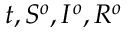<formula> <loc_0><loc_0><loc_500><loc_500>t , S ^ { o } , I ^ { o } , R ^ { o }</formula> 